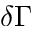<formula> <loc_0><loc_0><loc_500><loc_500>\delta \Gamma</formula> 